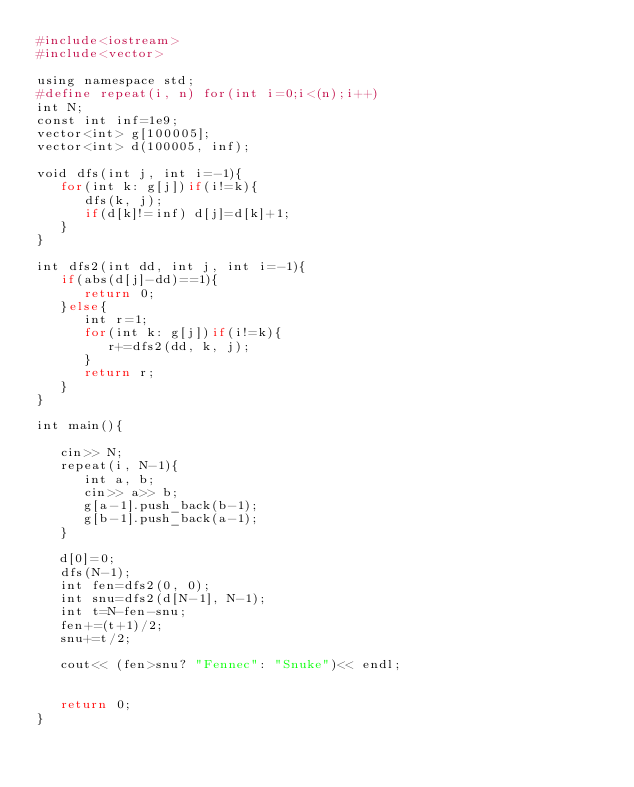Convert code to text. <code><loc_0><loc_0><loc_500><loc_500><_Ruby_>#include<iostream>
#include<vector>

using namespace std;
#define repeat(i, n) for(int i=0;i<(n);i++)
int N;
const int inf=1e9;
vector<int> g[100005];
vector<int> d(100005, inf);

void dfs(int j, int i=-1){
   for(int k: g[j])if(i!=k){
      dfs(k, j);
      if(d[k]!=inf) d[j]=d[k]+1;
   }
}

int dfs2(int dd, int j, int i=-1){
   if(abs(d[j]-dd)==1){
      return 0;
   }else{
      int r=1;
      for(int k: g[j])if(i!=k){
         r+=dfs2(dd, k, j);
      }
      return r;
   }
}

int main(){

   cin>> N;
   repeat(i, N-1){
      int a, b;
      cin>> a>> b;
      g[a-1].push_back(b-1);
      g[b-1].push_back(a-1);
   }

   d[0]=0;
   dfs(N-1);
   int fen=dfs2(0, 0);
   int snu=dfs2(d[N-1], N-1);
   int t=N-fen-snu;
   fen+=(t+1)/2;
   snu+=t/2;

   cout<< (fen>snu? "Fennec": "Snuke")<< endl;


   return 0;
}
</code> 